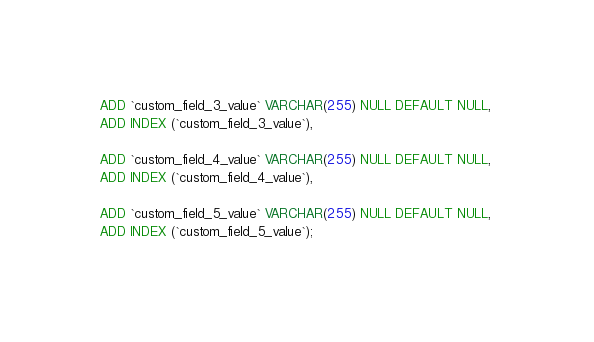<code> <loc_0><loc_0><loc_500><loc_500><_SQL_>ADD `custom_field_3_value` VARCHAR(255) NULL DEFAULT NULL, 
ADD INDEX (`custom_field_3_value`),

ADD `custom_field_4_value` VARCHAR(255) NULL DEFAULT NULL, 
ADD INDEX (`custom_field_4_value`),

ADD `custom_field_5_value` VARCHAR(255) NULL DEFAULT NULL, 
ADD INDEX (`custom_field_5_value`);</code> 